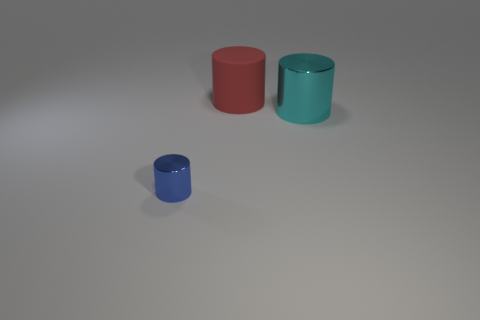Subtract all small metallic cylinders. How many cylinders are left? 2 Add 2 large cyan objects. How many objects exist? 5 Subtract 1 cylinders. How many cylinders are left? 2 Subtract all brown cylinders. Subtract all blue balls. How many cylinders are left? 3 Subtract all yellow cubes. How many blue cylinders are left? 1 Subtract all metal things. Subtract all small blue metal cylinders. How many objects are left? 0 Add 2 small blue things. How many small blue things are left? 3 Add 3 large cyan things. How many large cyan things exist? 4 Subtract 0 blue balls. How many objects are left? 3 